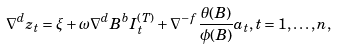Convert formula to latex. <formula><loc_0><loc_0><loc_500><loc_500>\nabla ^ { d } z _ { t } = \xi + \omega \nabla ^ { d } B ^ { b } I _ { t } ^ { ( T ) } + \nabla ^ { - f } \frac { \theta ( B ) } { \phi ( B ) } a _ { t } , t = 1 , \dots , n ,</formula> 